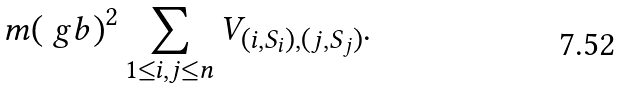<formula> <loc_0><loc_0><loc_500><loc_500>m ( \ g b ) ^ { 2 } \sum _ { 1 \leq i , j \leq n } V _ { ( i , S _ { i } ) , ( j , S _ { j } ) } .</formula> 